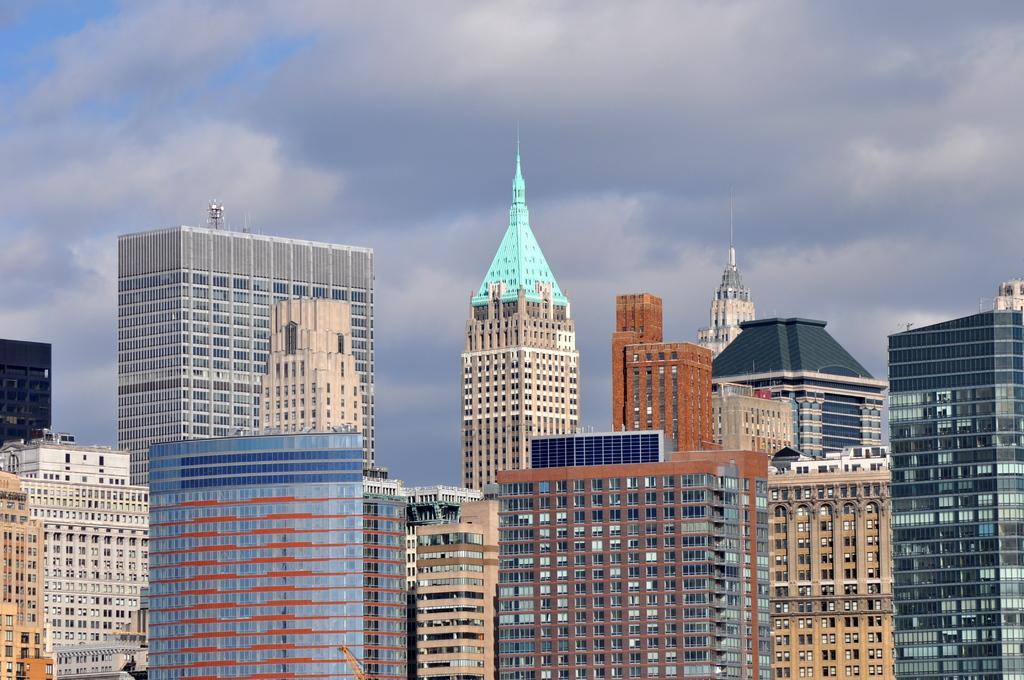Can you describe this image briefly? In this image there are big buildings, in the background there is a cloudy sky. 